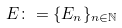<formula> <loc_0><loc_0><loc_500><loc_500>E \colon = \{ E _ { n } \} _ { n \in \mathbb { N } }</formula> 